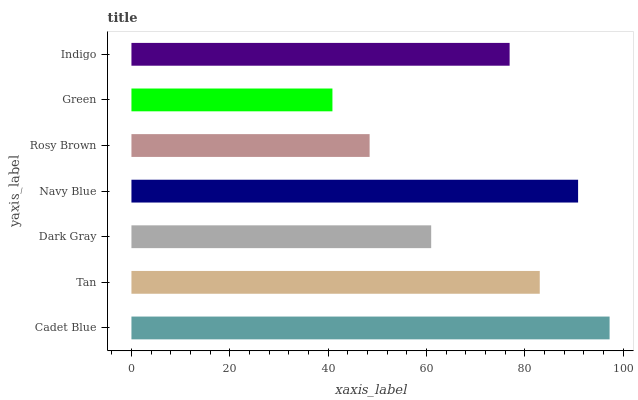Is Green the minimum?
Answer yes or no. Yes. Is Cadet Blue the maximum?
Answer yes or no. Yes. Is Tan the minimum?
Answer yes or no. No. Is Tan the maximum?
Answer yes or no. No. Is Cadet Blue greater than Tan?
Answer yes or no. Yes. Is Tan less than Cadet Blue?
Answer yes or no. Yes. Is Tan greater than Cadet Blue?
Answer yes or no. No. Is Cadet Blue less than Tan?
Answer yes or no. No. Is Indigo the high median?
Answer yes or no. Yes. Is Indigo the low median?
Answer yes or no. Yes. Is Navy Blue the high median?
Answer yes or no. No. Is Rosy Brown the low median?
Answer yes or no. No. 